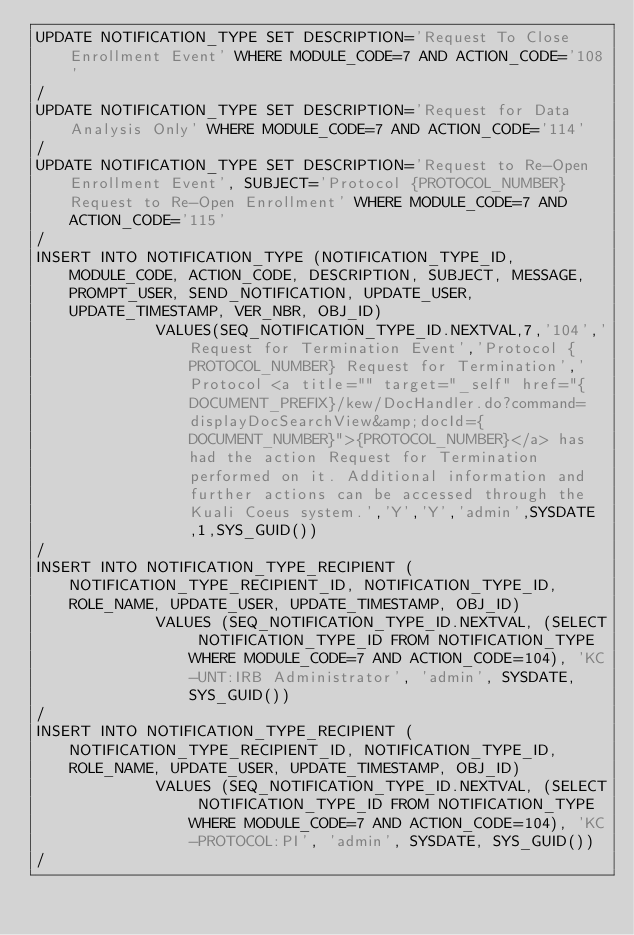<code> <loc_0><loc_0><loc_500><loc_500><_SQL_>UPDATE NOTIFICATION_TYPE SET DESCRIPTION='Request To Close Enrollment Event' WHERE MODULE_CODE=7 AND ACTION_CODE='108'
/
UPDATE NOTIFICATION_TYPE SET DESCRIPTION='Request for Data Analysis Only' WHERE MODULE_CODE=7 AND ACTION_CODE='114'
/
UPDATE NOTIFICATION_TYPE SET DESCRIPTION='Request to Re-Open Enrollment Event', SUBJECT='Protocol {PROTOCOL_NUMBER} Request to Re-Open Enrollment' WHERE MODULE_CODE=7 AND ACTION_CODE='115'
/
INSERT INTO NOTIFICATION_TYPE (NOTIFICATION_TYPE_ID, MODULE_CODE, ACTION_CODE, DESCRIPTION, SUBJECT, MESSAGE, PROMPT_USER, SEND_NOTIFICATION, UPDATE_USER, UPDATE_TIMESTAMP, VER_NBR, OBJ_ID)
             VALUES(SEQ_NOTIFICATION_TYPE_ID.NEXTVAL,7,'104','Request for Termination Event','Protocol {PROTOCOL_NUMBER} Request for Termination','Protocol <a title="" target="_self" href="{DOCUMENT_PREFIX}/kew/DocHandler.do?command=displayDocSearchView&amp;docId={DOCUMENT_NUMBER}">{PROTOCOL_NUMBER}</a> has had the action Request for Termination performed on it. Additional information and further actions can be accessed through the Kuali Coeus system.','Y','Y','admin',SYSDATE,1,SYS_GUID())
/
INSERT INTO NOTIFICATION_TYPE_RECIPIENT (NOTIFICATION_TYPE_RECIPIENT_ID, NOTIFICATION_TYPE_ID, ROLE_NAME, UPDATE_USER, UPDATE_TIMESTAMP, OBJ_ID)
             VALUES (SEQ_NOTIFICATION_TYPE_ID.NEXTVAL, (SELECT NOTIFICATION_TYPE_ID FROM NOTIFICATION_TYPE WHERE MODULE_CODE=7 AND ACTION_CODE=104), 'KC-UNT:IRB Administrator', 'admin', SYSDATE, SYS_GUID())
/
INSERT INTO NOTIFICATION_TYPE_RECIPIENT (NOTIFICATION_TYPE_RECIPIENT_ID, NOTIFICATION_TYPE_ID, ROLE_NAME, UPDATE_USER, UPDATE_TIMESTAMP, OBJ_ID)
             VALUES (SEQ_NOTIFICATION_TYPE_ID.NEXTVAL, (SELECT NOTIFICATION_TYPE_ID FROM NOTIFICATION_TYPE WHERE MODULE_CODE=7 AND ACTION_CODE=104), 'KC-PROTOCOL:PI', 'admin', SYSDATE, SYS_GUID()) 
/

</code> 